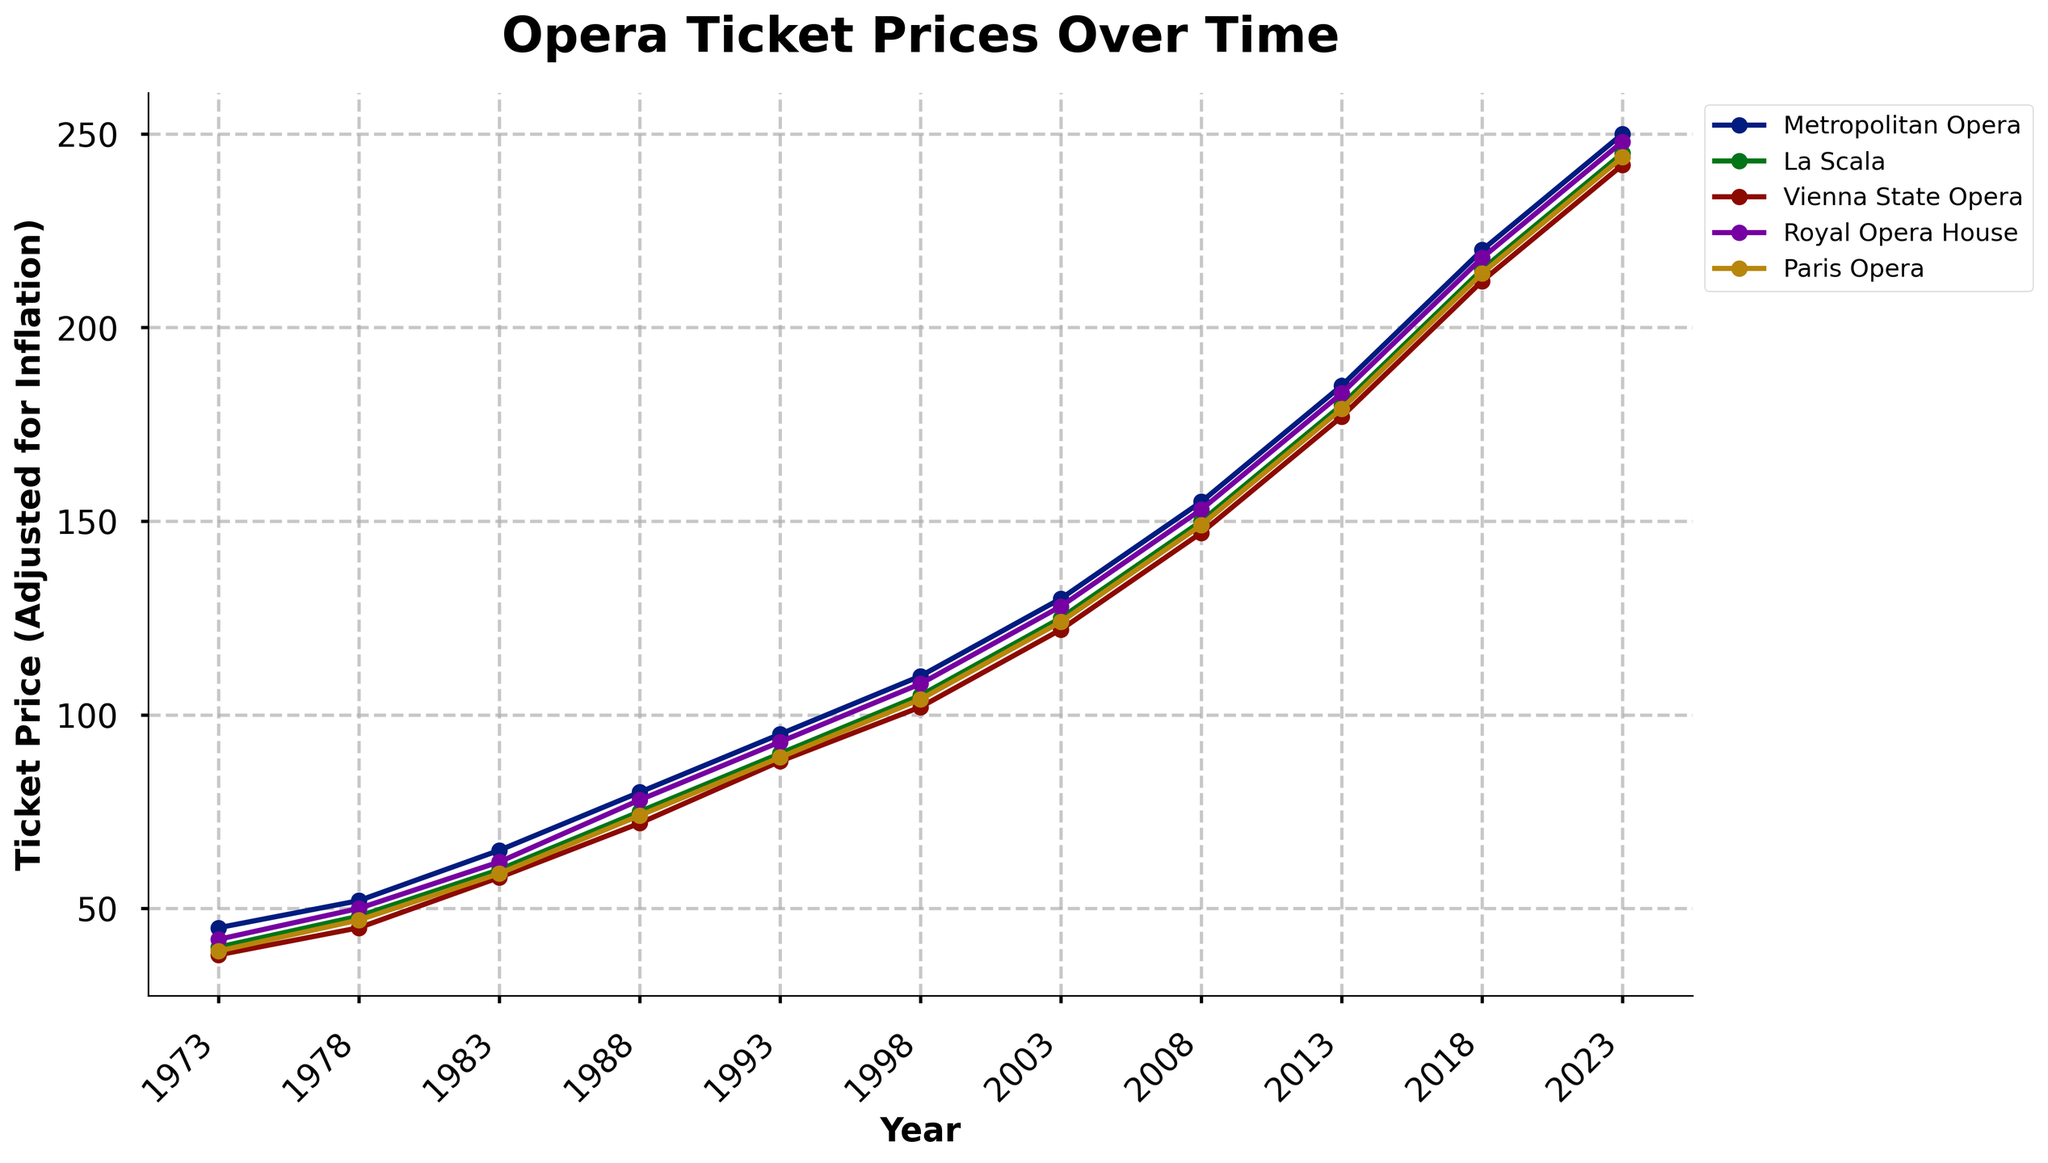What was the ticket price of the Metropolitan Opera in 1993? Locate the year 1993 along the x-axis and find the corresponding value for the Metropolitan Opera line.
Answer: 95 How much did ticket prices for La Scala increase from 1973 to 2023? Find the ticket price for La Scala in 1973 and 2023 from the plot. Then, calculate the increase by subtracting the 1973 value from the 2023 value (245 - 40).
Answer: 205 Which opera house had the highest ticket price in 2018? Identify the point on the x-axis corresponding to the year 2018, and compare the ticket prices of all opera houses at that point.
Answer: Metropolitan Opera Between 2008 and 2013, which opera house had the largest increase in ticket prices? Find the ticket prices for all opera houses in 2008 and 2013, then calculate the increase for each by subtracting 2008 values from 2013 values. Compare these increases to find the largest one.
Answer: Metropolitan Opera Is there any year where the ticket price for the Royal Opera House exceeded that of the Metropolitan Opera? Compare the ticket prices for the Royal Opera House and the Metropolitan Opera across all the years presented in the plot.
Answer: No What is the average ticket price for Vienna State Opera across the years presented in the plot? Sum all the ticket prices for Vienna State Opera and divide by the number of years: (38 + 45 + 58 + 72 + 88 + 102 + 122 + 147 + 177 + 212 + 242) / 11.
Answer: 129.55 Which opera house had the least increase in ticket prices from 1973 to 2023? For each opera house, calculate the difference in ticket prices from 1973 to 2023, and then identify the smallest increase.
Answer: Paris Opera Did the ticket price for the Paris Opera ever exceed 200 within the illustrated time period? Inspect the plot to see if the ticket prices for the Paris Opera ever reached or exceeded 200 across the years.
Answer: No 